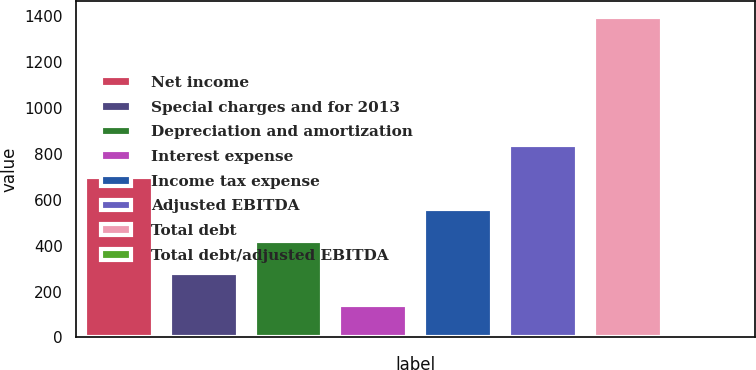Convert chart to OTSL. <chart><loc_0><loc_0><loc_500><loc_500><bar_chart><fcel>Net income<fcel>Special charges and for 2013<fcel>Depreciation and amortization<fcel>Interest expense<fcel>Income tax expense<fcel>Adjusted EBITDA<fcel>Total debt<fcel>Total debt/adjusted EBITDA<nl><fcel>698.76<fcel>280.62<fcel>420<fcel>141.24<fcel>559.38<fcel>838.14<fcel>1395.7<fcel>1.85<nl></chart> 